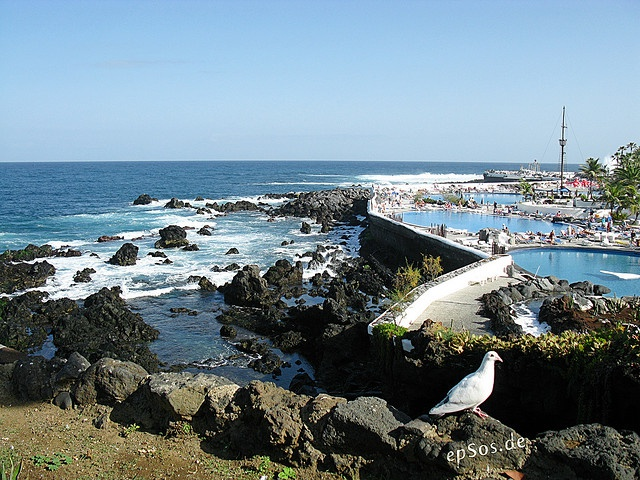Describe the objects in this image and their specific colors. I can see bird in lightblue, white, darkgray, gray, and black tones, boat in lightblue, darkgray, lightgray, gray, and black tones, people in lightblue, black, lightgray, gray, and darkgray tones, people in lightblue, black, maroon, brown, and tan tones, and people in lightblue, darkgray, and white tones in this image. 